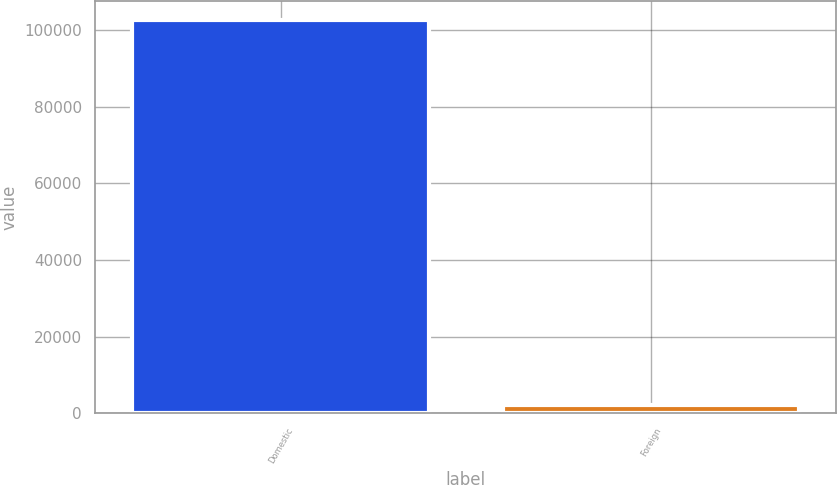<chart> <loc_0><loc_0><loc_500><loc_500><bar_chart><fcel>Domestic<fcel>Foreign<nl><fcel>102498<fcel>2156<nl></chart> 